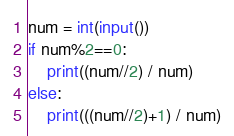<code> <loc_0><loc_0><loc_500><loc_500><_Python_>num = int(input())
if num%2==0:
    print((num//2) / num)
else:
    print(((num//2)+1) / num)</code> 